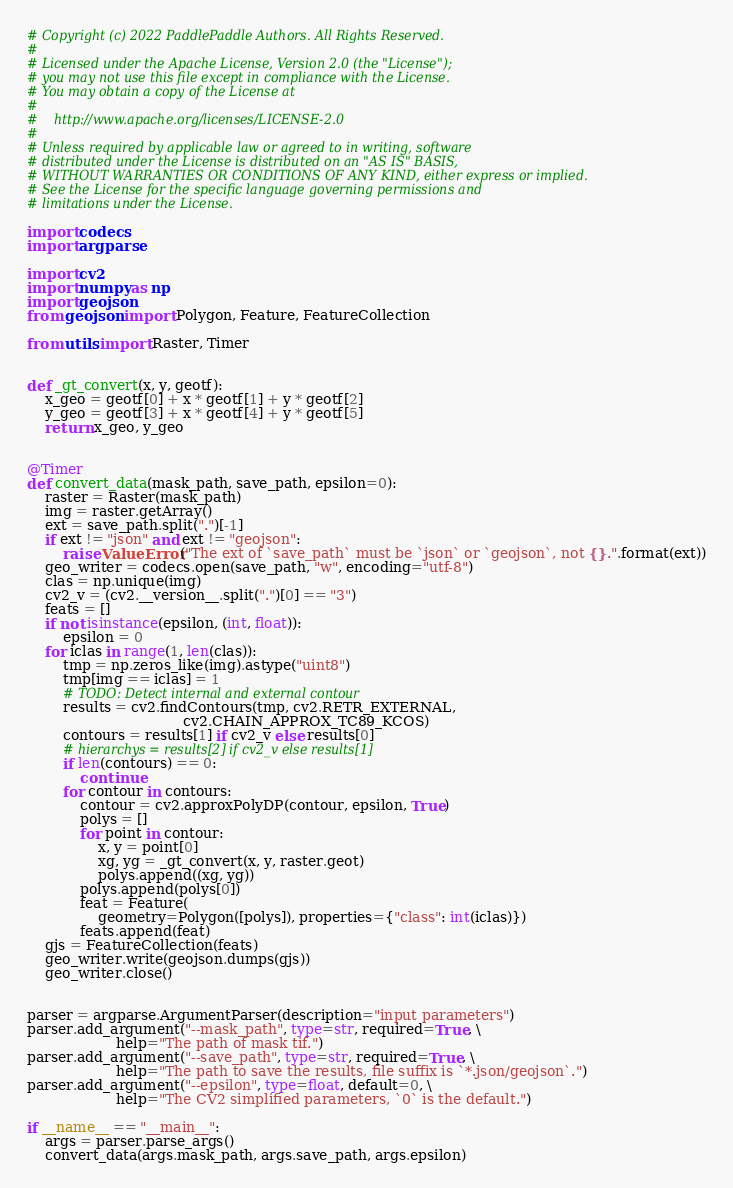<code> <loc_0><loc_0><loc_500><loc_500><_Python_># Copyright (c) 2022 PaddlePaddle Authors. All Rights Reserved.
#
# Licensed under the Apache License, Version 2.0 (the "License");
# you may not use this file except in compliance with the License.
# You may obtain a copy of the License at
#
#    http://www.apache.org/licenses/LICENSE-2.0
#
# Unless required by applicable law or agreed to in writing, software
# distributed under the License is distributed on an "AS IS" BASIS,
# WITHOUT WARRANTIES OR CONDITIONS OF ANY KIND, either express or implied.
# See the License for the specific language governing permissions and
# limitations under the License.

import codecs
import argparse

import cv2
import numpy as np
import geojson
from geojson import Polygon, Feature, FeatureCollection

from utils import Raster, Timer


def _gt_convert(x, y, geotf):
    x_geo = geotf[0] + x * geotf[1] + y * geotf[2]
    y_geo = geotf[3] + x * geotf[4] + y * geotf[5]
    return x_geo, y_geo


@Timer
def convert_data(mask_path, save_path, epsilon=0):
    raster = Raster(mask_path)
    img = raster.getArray()
    ext = save_path.split(".")[-1]
    if ext != "json" and ext != "geojson":
        raise ValueError("The ext of `save_path` must be `json` or `geojson`, not {}.".format(ext))
    geo_writer = codecs.open(save_path, "w", encoding="utf-8")
    clas = np.unique(img)
    cv2_v = (cv2.__version__.split(".")[0] == "3")
    feats = []
    if not isinstance(epsilon, (int, float)):
        epsilon = 0
    for iclas in range(1, len(clas)):
        tmp = np.zeros_like(img).astype("uint8")
        tmp[img == iclas] = 1
        # TODO: Detect internal and external contour
        results = cv2.findContours(tmp, cv2.RETR_EXTERNAL,
                                   cv2.CHAIN_APPROX_TC89_KCOS)
        contours = results[1] if cv2_v else results[0]
        # hierarchys = results[2] if cv2_v else results[1]
        if len(contours) == 0:
            continue
        for contour in contours:
            contour = cv2.approxPolyDP(contour, epsilon, True)
            polys = []
            for point in contour:
                x, y = point[0]
                xg, yg = _gt_convert(x, y, raster.geot)
                polys.append((xg, yg))
            polys.append(polys[0])
            feat = Feature(
                geometry=Polygon([polys]), properties={"class": int(iclas)})
            feats.append(feat)
    gjs = FeatureCollection(feats)
    geo_writer.write(geojson.dumps(gjs))
    geo_writer.close()


parser = argparse.ArgumentParser(description="input parameters")
parser.add_argument("--mask_path", type=str, required=True, \
                    help="The path of mask tif.")
parser.add_argument("--save_path", type=str, required=True, \
                    help="The path to save the results, file suffix is `*.json/geojson`.")
parser.add_argument("--epsilon", type=float, default=0, \
                    help="The CV2 simplified parameters, `0` is the default.")

if __name__ == "__main__":
    args = parser.parse_args()
    convert_data(args.mask_path, args.save_path, args.epsilon)
</code> 